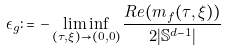<formula> <loc_0><loc_0><loc_500><loc_500>\epsilon _ { g } \colon = - \liminf _ { ( \tau , \xi ) \to ( 0 , 0 ) } \frac { R e ( m _ { f } ( \tau , \xi ) ) } { 2 | \mathbb { S } ^ { d - 1 } | }</formula> 